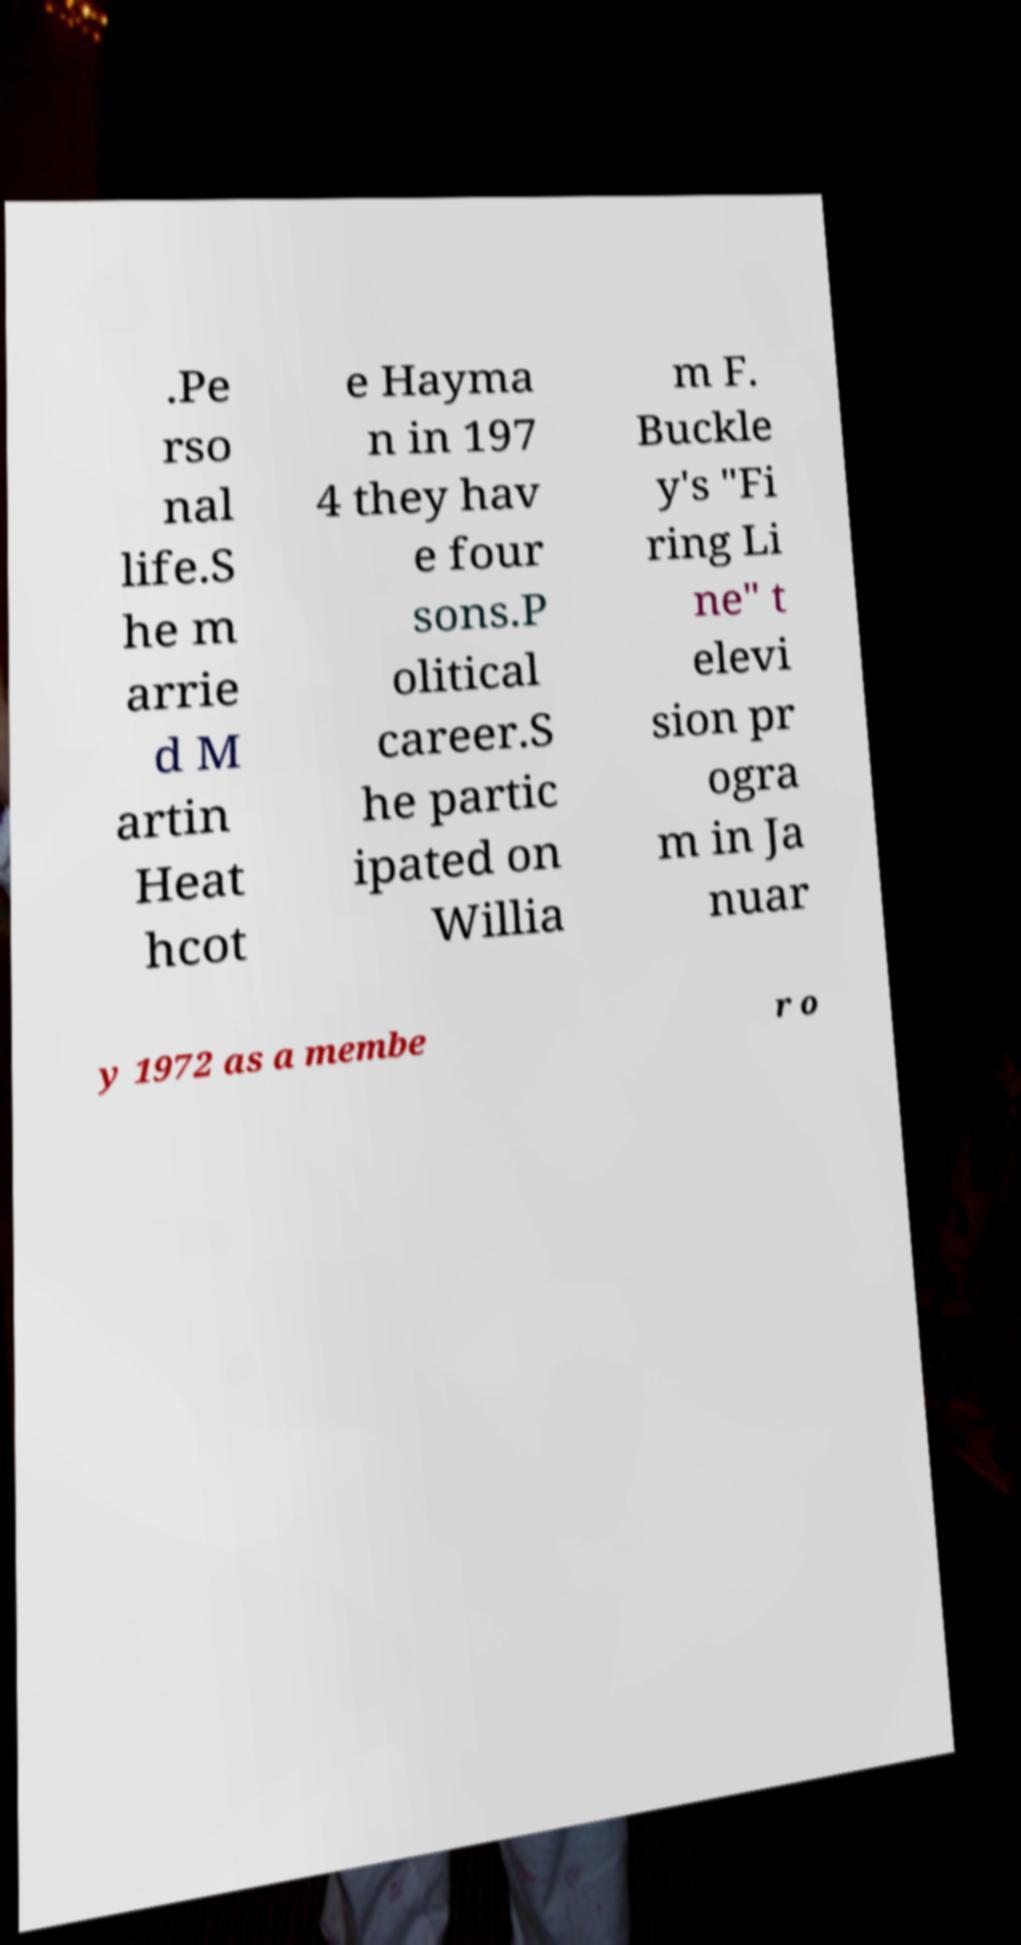Can you read and provide the text displayed in the image?This photo seems to have some interesting text. Can you extract and type it out for me? .Pe rso nal life.S he m arrie d M artin Heat hcot e Hayma n in 197 4 they hav e four sons.P olitical career.S he partic ipated on Willia m F. Buckle y's "Fi ring Li ne" t elevi sion pr ogra m in Ja nuar y 1972 as a membe r o 